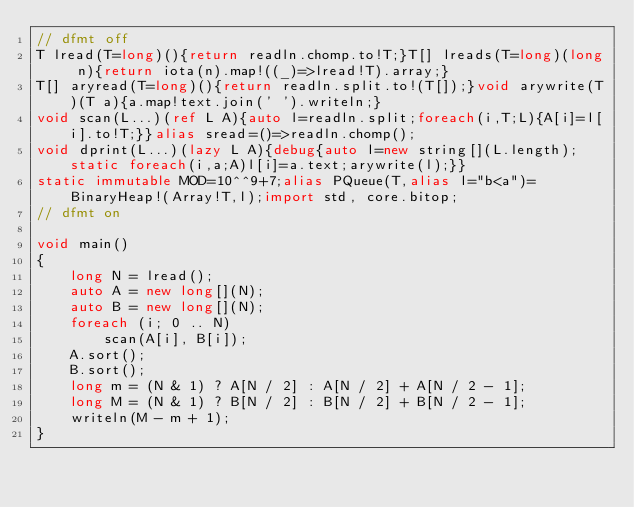Convert code to text. <code><loc_0><loc_0><loc_500><loc_500><_D_>// dfmt off
T lread(T=long)(){return readln.chomp.to!T;}T[] lreads(T=long)(long n){return iota(n).map!((_)=>lread!T).array;}
T[] aryread(T=long)(){return readln.split.to!(T[]);}void arywrite(T)(T a){a.map!text.join(' ').writeln;}
void scan(L...)(ref L A){auto l=readln.split;foreach(i,T;L){A[i]=l[i].to!T;}}alias sread=()=>readln.chomp();
void dprint(L...)(lazy L A){debug{auto l=new string[](L.length);static foreach(i,a;A)l[i]=a.text;arywrite(l);}}
static immutable MOD=10^^9+7;alias PQueue(T,alias l="b<a")=BinaryHeap!(Array!T,l);import std, core.bitop;
// dfmt on

void main()
{
    long N = lread();
    auto A = new long[](N);
    auto B = new long[](N);
    foreach (i; 0 .. N)
        scan(A[i], B[i]);
    A.sort();
    B.sort();
    long m = (N & 1) ? A[N / 2] : A[N / 2] + A[N / 2 - 1];
    long M = (N & 1) ? B[N / 2] : B[N / 2] + B[N / 2 - 1];
    writeln(M - m + 1);
}
</code> 